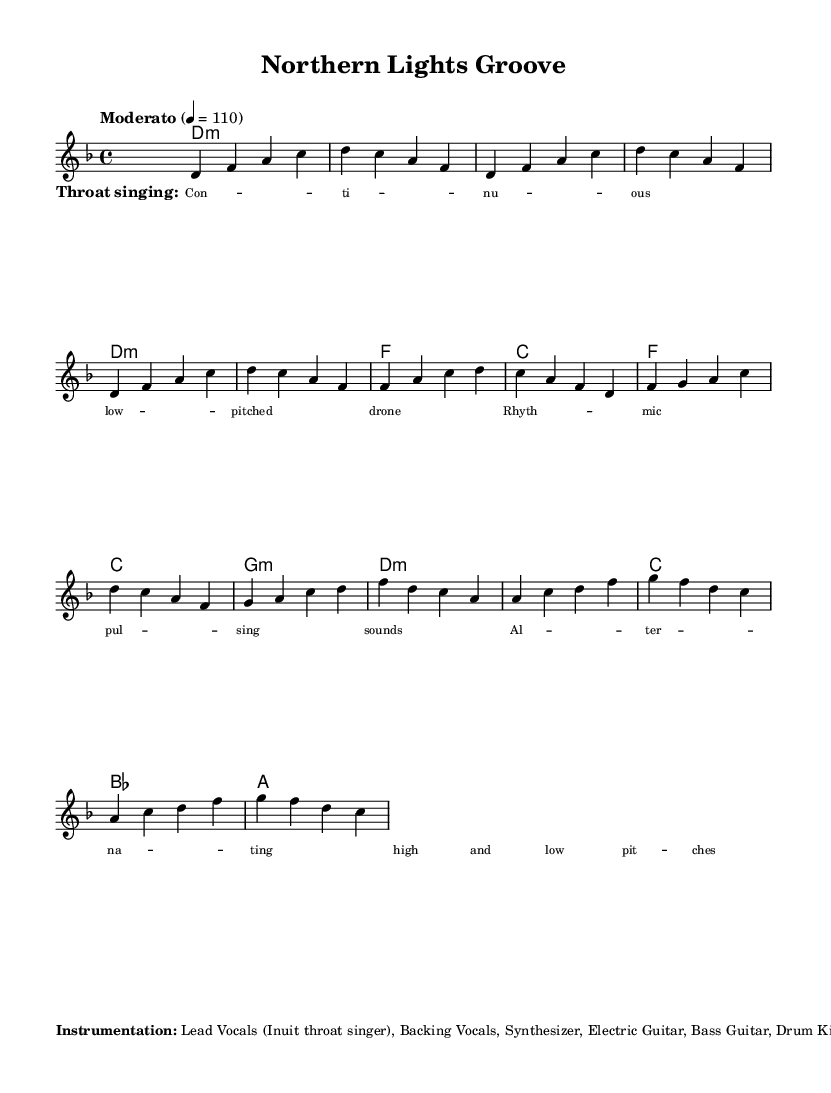What is the key signature of this music? The key signature is D minor, which contains one flat (B♭). It can be identified through the key signature notation at the beginning of the sheet music.
Answer: D minor What is the time signature of this piece? The time signature is 4/4, indicating four beats in each measure, and can be found at the beginning of the score next to the key signature.
Answer: 4/4 What is the tempo marking for the song? The tempo marking is "Moderato" at a speed of quarter note equals 110 beats per minute, which is indicated in the tempo directive at the start of the score.
Answer: Moderato 4 = 110 How many sections are in the structure of the song? The structure includes seven sections: Intro, Verse 1, Chorus, Verse 2, Chorus, Bridge, and Outro. This can be inferred from the labeled sections in the markup beside the sheet music.
Answer: 7 Which vocal technique is incorporated into the song? The song features Inuit throat singing, highlighted in the lyrics section where the style and techniques are explicitly mentioned.
Answer: Throat singing What is the role of the synthesizer in this composition? The synthesizer is used for creating ambient, aurora-like textures, as noted in the additional notes in the markup. This enhances the atmospheric quality of the music.
Answer: Ambient textures What instruments accompany the lead vocals in this piece? The instrumentation includes Backing Vocals, Synthesizer, Electric Guitar, Bass Guitar, and Drum Kit, as detailed in the instrumentation notes of the markup.
Answer: Backing Vocals, Synthesizer, Electric Guitar, Bass Guitar, Drum Kit 